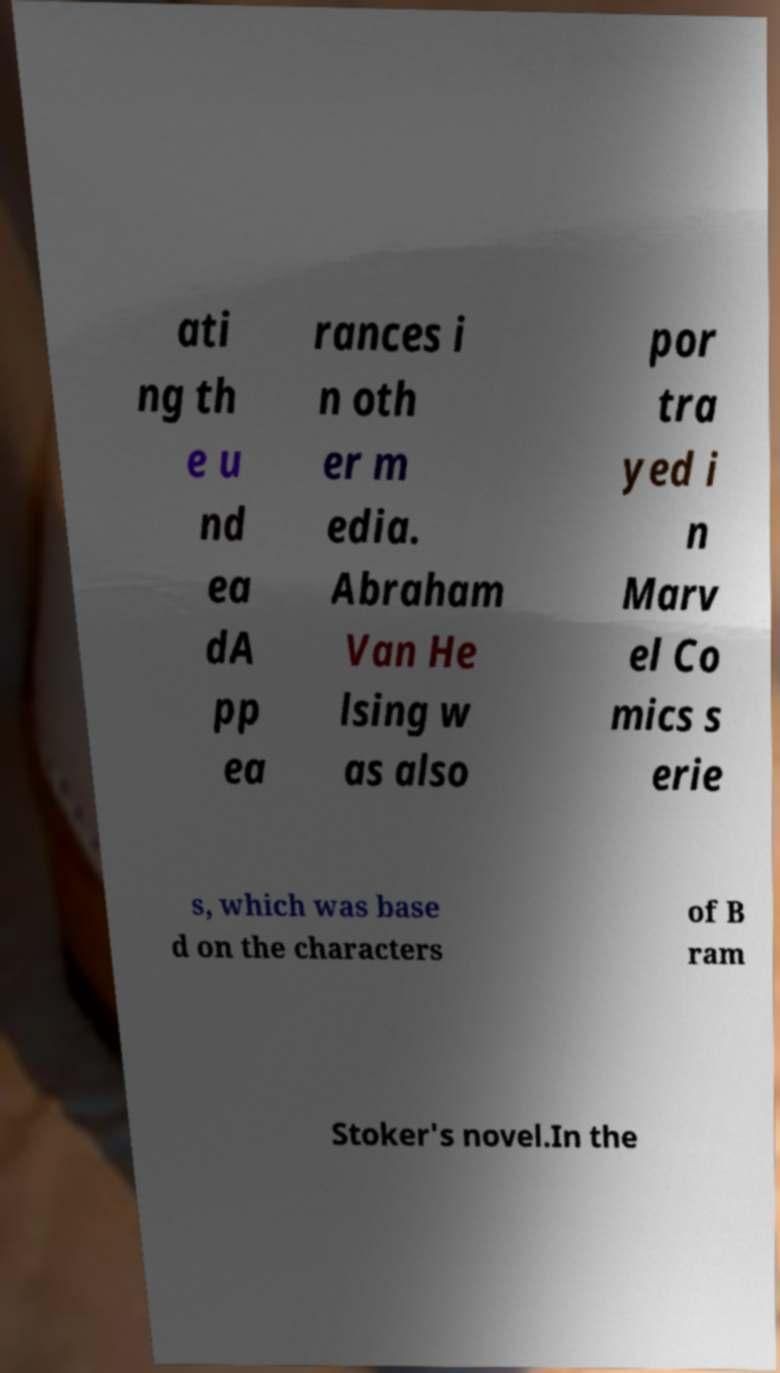Could you assist in decoding the text presented in this image and type it out clearly? ati ng th e u nd ea dA pp ea rances i n oth er m edia. Abraham Van He lsing w as also por tra yed i n Marv el Co mics s erie s, which was base d on the characters of B ram Stoker's novel.In the 